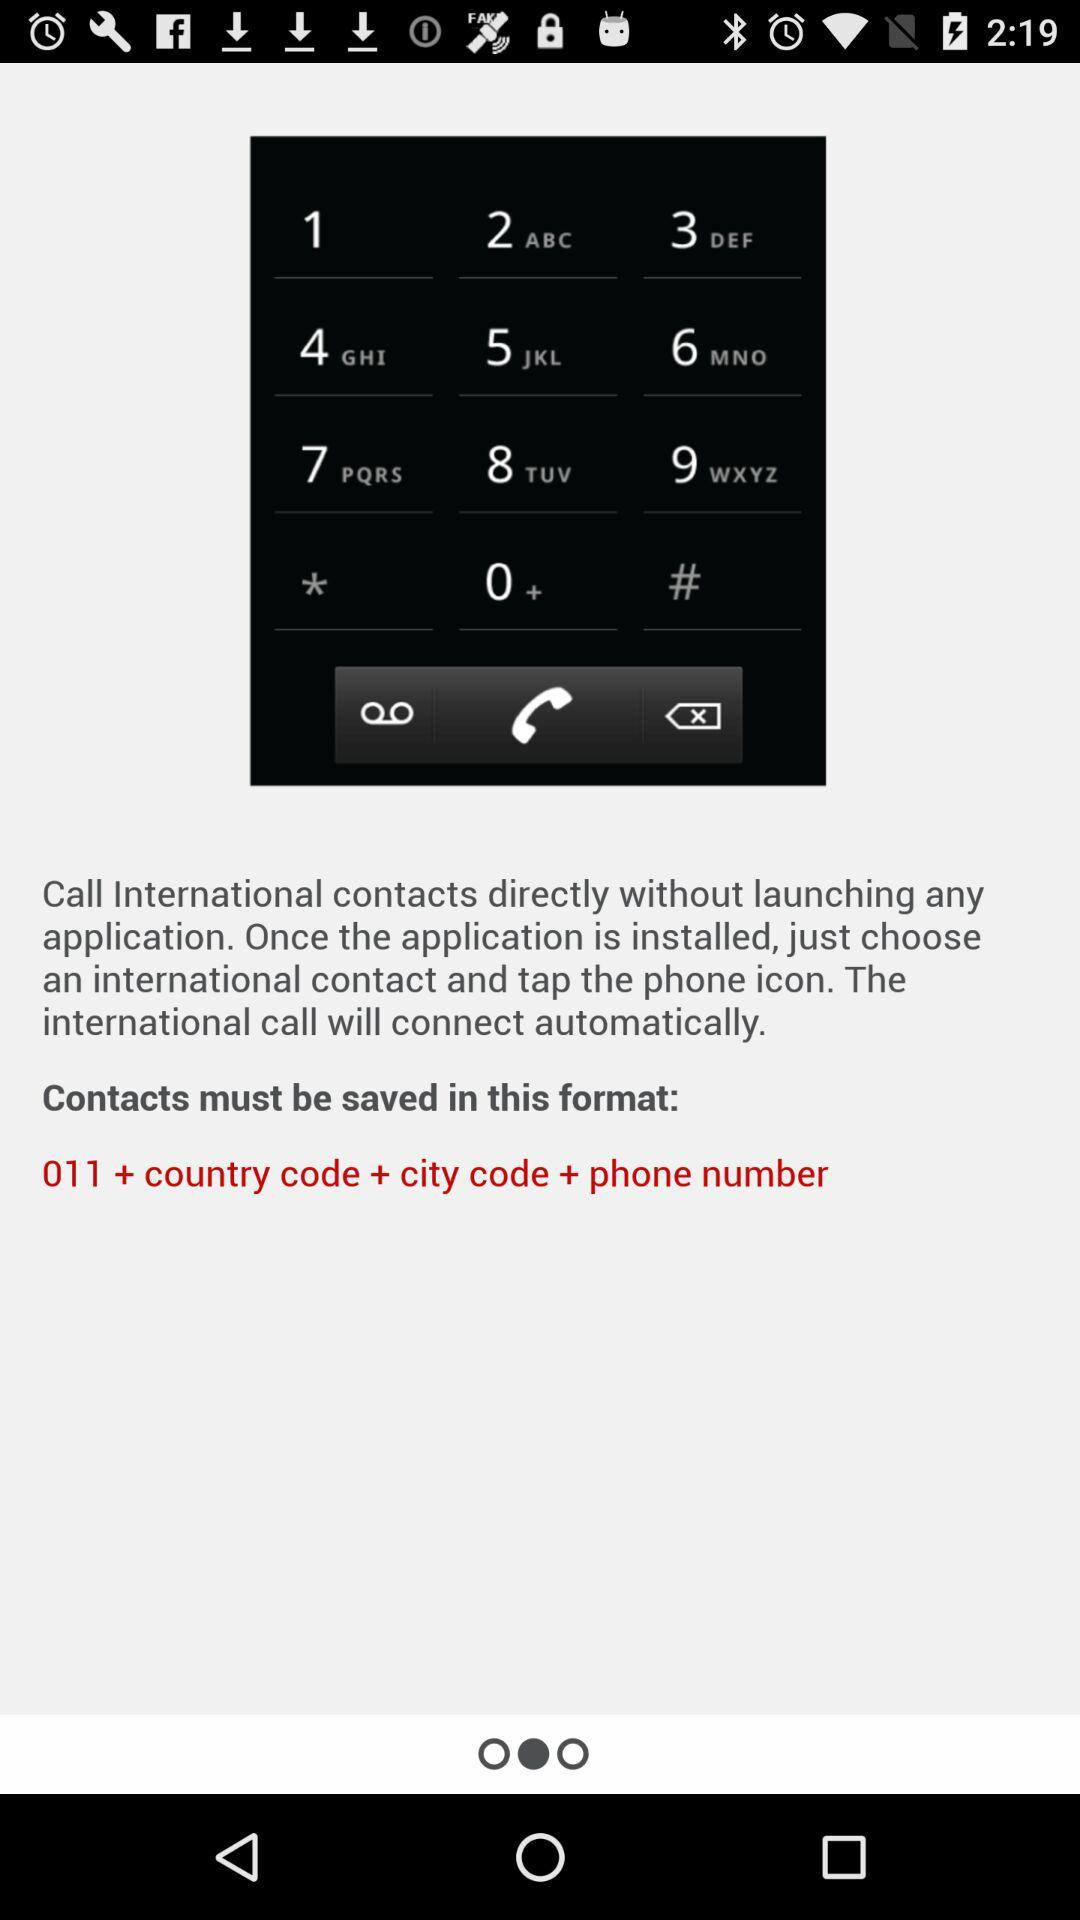In what format does the contact have to be saved? The contact has to be saved in the format "011 + country code + city code + phone number". 